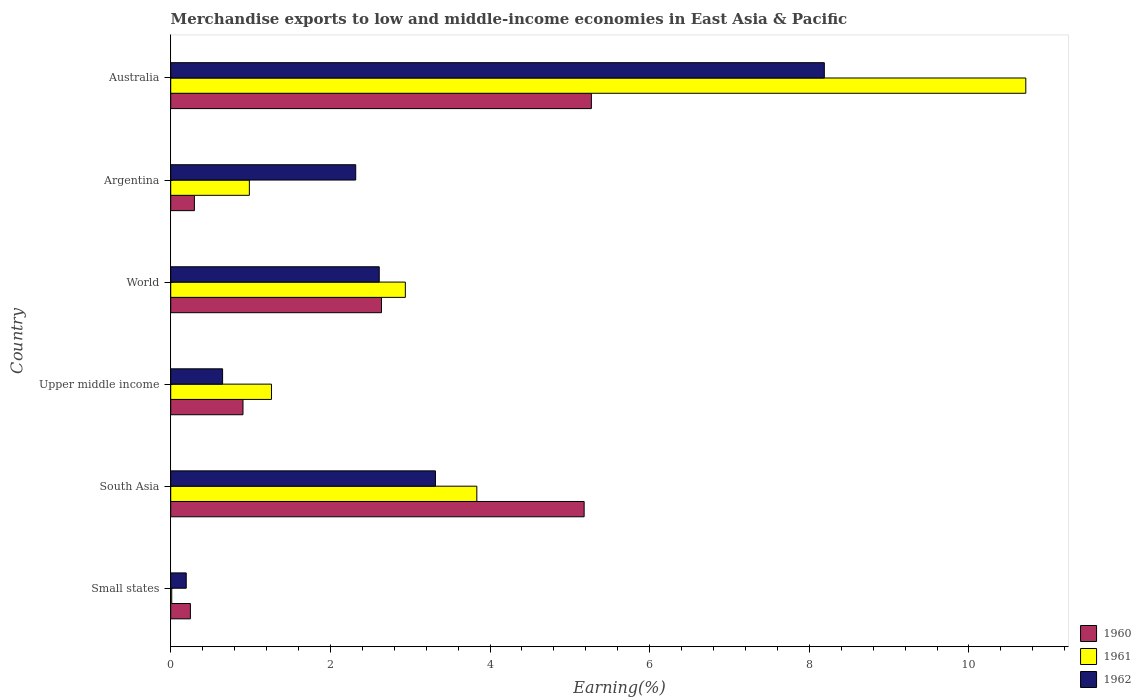How many different coloured bars are there?
Ensure brevity in your answer.  3. How many groups of bars are there?
Ensure brevity in your answer.  6. Are the number of bars per tick equal to the number of legend labels?
Your response must be concise. Yes. How many bars are there on the 5th tick from the top?
Your answer should be very brief. 3. What is the label of the 3rd group of bars from the top?
Your response must be concise. World. In how many cases, is the number of bars for a given country not equal to the number of legend labels?
Make the answer very short. 0. What is the percentage of amount earned from merchandise exports in 1961 in Small states?
Keep it short and to the point. 0.01. Across all countries, what is the maximum percentage of amount earned from merchandise exports in 1962?
Keep it short and to the point. 8.19. Across all countries, what is the minimum percentage of amount earned from merchandise exports in 1960?
Your answer should be compact. 0.25. In which country was the percentage of amount earned from merchandise exports in 1962 maximum?
Your answer should be very brief. Australia. In which country was the percentage of amount earned from merchandise exports in 1960 minimum?
Your answer should be very brief. Small states. What is the total percentage of amount earned from merchandise exports in 1960 in the graph?
Keep it short and to the point. 14.54. What is the difference between the percentage of amount earned from merchandise exports in 1961 in Australia and that in World?
Ensure brevity in your answer.  7.77. What is the difference between the percentage of amount earned from merchandise exports in 1962 in South Asia and the percentage of amount earned from merchandise exports in 1961 in Australia?
Keep it short and to the point. -7.4. What is the average percentage of amount earned from merchandise exports in 1960 per country?
Your response must be concise. 2.42. What is the difference between the percentage of amount earned from merchandise exports in 1961 and percentage of amount earned from merchandise exports in 1960 in Small states?
Offer a very short reply. -0.23. In how many countries, is the percentage of amount earned from merchandise exports in 1961 greater than 7.6 %?
Keep it short and to the point. 1. What is the ratio of the percentage of amount earned from merchandise exports in 1961 in Argentina to that in South Asia?
Give a very brief answer. 0.26. Is the difference between the percentage of amount earned from merchandise exports in 1961 in South Asia and World greater than the difference between the percentage of amount earned from merchandise exports in 1960 in South Asia and World?
Your response must be concise. No. What is the difference between the highest and the second highest percentage of amount earned from merchandise exports in 1962?
Ensure brevity in your answer.  4.87. What is the difference between the highest and the lowest percentage of amount earned from merchandise exports in 1960?
Provide a succinct answer. 5.02. In how many countries, is the percentage of amount earned from merchandise exports in 1962 greater than the average percentage of amount earned from merchandise exports in 1962 taken over all countries?
Your answer should be compact. 2. Is the sum of the percentage of amount earned from merchandise exports in 1960 in Australia and South Asia greater than the maximum percentage of amount earned from merchandise exports in 1961 across all countries?
Keep it short and to the point. No. What does the 3rd bar from the bottom in Australia represents?
Offer a very short reply. 1962. Is it the case that in every country, the sum of the percentage of amount earned from merchandise exports in 1960 and percentage of amount earned from merchandise exports in 1962 is greater than the percentage of amount earned from merchandise exports in 1961?
Offer a terse response. Yes. Are all the bars in the graph horizontal?
Provide a succinct answer. Yes. How many countries are there in the graph?
Your answer should be very brief. 6. Are the values on the major ticks of X-axis written in scientific E-notation?
Your response must be concise. No. What is the title of the graph?
Provide a short and direct response. Merchandise exports to low and middle-income economies in East Asia & Pacific. Does "2011" appear as one of the legend labels in the graph?
Provide a succinct answer. No. What is the label or title of the X-axis?
Your response must be concise. Earning(%). What is the label or title of the Y-axis?
Offer a terse response. Country. What is the Earning(%) of 1960 in Small states?
Give a very brief answer. 0.25. What is the Earning(%) in 1961 in Small states?
Your response must be concise. 0.01. What is the Earning(%) in 1962 in Small states?
Provide a succinct answer. 0.19. What is the Earning(%) of 1960 in South Asia?
Offer a very short reply. 5.18. What is the Earning(%) of 1961 in South Asia?
Your answer should be compact. 3.83. What is the Earning(%) in 1962 in South Asia?
Provide a short and direct response. 3.32. What is the Earning(%) of 1960 in Upper middle income?
Provide a succinct answer. 0.91. What is the Earning(%) of 1961 in Upper middle income?
Your response must be concise. 1.26. What is the Earning(%) in 1962 in Upper middle income?
Give a very brief answer. 0.65. What is the Earning(%) in 1960 in World?
Provide a short and direct response. 2.64. What is the Earning(%) in 1961 in World?
Provide a short and direct response. 2.94. What is the Earning(%) of 1962 in World?
Ensure brevity in your answer.  2.61. What is the Earning(%) of 1960 in Argentina?
Your response must be concise. 0.3. What is the Earning(%) in 1961 in Argentina?
Offer a very short reply. 0.99. What is the Earning(%) in 1962 in Argentina?
Give a very brief answer. 2.32. What is the Earning(%) of 1960 in Australia?
Provide a short and direct response. 5.27. What is the Earning(%) of 1961 in Australia?
Keep it short and to the point. 10.71. What is the Earning(%) of 1962 in Australia?
Offer a very short reply. 8.19. Across all countries, what is the maximum Earning(%) in 1960?
Your answer should be compact. 5.27. Across all countries, what is the maximum Earning(%) in 1961?
Keep it short and to the point. 10.71. Across all countries, what is the maximum Earning(%) in 1962?
Ensure brevity in your answer.  8.19. Across all countries, what is the minimum Earning(%) of 1960?
Provide a short and direct response. 0.25. Across all countries, what is the minimum Earning(%) in 1961?
Your response must be concise. 0.01. Across all countries, what is the minimum Earning(%) in 1962?
Give a very brief answer. 0.19. What is the total Earning(%) in 1960 in the graph?
Your response must be concise. 14.54. What is the total Earning(%) in 1961 in the graph?
Offer a terse response. 19.75. What is the total Earning(%) of 1962 in the graph?
Keep it short and to the point. 17.28. What is the difference between the Earning(%) in 1960 in Small states and that in South Asia?
Make the answer very short. -4.93. What is the difference between the Earning(%) of 1961 in Small states and that in South Asia?
Your answer should be very brief. -3.82. What is the difference between the Earning(%) of 1962 in Small states and that in South Asia?
Ensure brevity in your answer.  -3.12. What is the difference between the Earning(%) in 1960 in Small states and that in Upper middle income?
Ensure brevity in your answer.  -0.66. What is the difference between the Earning(%) in 1961 in Small states and that in Upper middle income?
Keep it short and to the point. -1.25. What is the difference between the Earning(%) of 1962 in Small states and that in Upper middle income?
Give a very brief answer. -0.46. What is the difference between the Earning(%) in 1960 in Small states and that in World?
Ensure brevity in your answer.  -2.39. What is the difference between the Earning(%) in 1961 in Small states and that in World?
Offer a very short reply. -2.93. What is the difference between the Earning(%) of 1962 in Small states and that in World?
Keep it short and to the point. -2.42. What is the difference between the Earning(%) of 1960 in Small states and that in Argentina?
Provide a short and direct response. -0.05. What is the difference between the Earning(%) of 1961 in Small states and that in Argentina?
Your answer should be compact. -0.97. What is the difference between the Earning(%) in 1962 in Small states and that in Argentina?
Your response must be concise. -2.12. What is the difference between the Earning(%) of 1960 in Small states and that in Australia?
Your response must be concise. -5.02. What is the difference between the Earning(%) in 1961 in Small states and that in Australia?
Give a very brief answer. -10.7. What is the difference between the Earning(%) of 1962 in Small states and that in Australia?
Your response must be concise. -7.99. What is the difference between the Earning(%) of 1960 in South Asia and that in Upper middle income?
Your answer should be compact. 4.27. What is the difference between the Earning(%) in 1961 in South Asia and that in Upper middle income?
Your answer should be very brief. 2.57. What is the difference between the Earning(%) of 1962 in South Asia and that in Upper middle income?
Ensure brevity in your answer.  2.67. What is the difference between the Earning(%) of 1960 in South Asia and that in World?
Give a very brief answer. 2.54. What is the difference between the Earning(%) of 1961 in South Asia and that in World?
Keep it short and to the point. 0.9. What is the difference between the Earning(%) of 1962 in South Asia and that in World?
Your answer should be compact. 0.7. What is the difference between the Earning(%) in 1960 in South Asia and that in Argentina?
Your answer should be very brief. 4.88. What is the difference between the Earning(%) in 1961 in South Asia and that in Argentina?
Provide a short and direct response. 2.85. What is the difference between the Earning(%) in 1962 in South Asia and that in Argentina?
Give a very brief answer. 1. What is the difference between the Earning(%) of 1960 in South Asia and that in Australia?
Provide a short and direct response. -0.09. What is the difference between the Earning(%) in 1961 in South Asia and that in Australia?
Give a very brief answer. -6.88. What is the difference between the Earning(%) in 1962 in South Asia and that in Australia?
Ensure brevity in your answer.  -4.87. What is the difference between the Earning(%) in 1960 in Upper middle income and that in World?
Keep it short and to the point. -1.74. What is the difference between the Earning(%) in 1961 in Upper middle income and that in World?
Give a very brief answer. -1.68. What is the difference between the Earning(%) of 1962 in Upper middle income and that in World?
Offer a very short reply. -1.96. What is the difference between the Earning(%) of 1960 in Upper middle income and that in Argentina?
Keep it short and to the point. 0.61. What is the difference between the Earning(%) in 1961 in Upper middle income and that in Argentina?
Your answer should be very brief. 0.28. What is the difference between the Earning(%) of 1962 in Upper middle income and that in Argentina?
Offer a terse response. -1.67. What is the difference between the Earning(%) of 1960 in Upper middle income and that in Australia?
Your answer should be very brief. -4.36. What is the difference between the Earning(%) of 1961 in Upper middle income and that in Australia?
Provide a succinct answer. -9.45. What is the difference between the Earning(%) of 1962 in Upper middle income and that in Australia?
Provide a succinct answer. -7.54. What is the difference between the Earning(%) of 1960 in World and that in Argentina?
Make the answer very short. 2.34. What is the difference between the Earning(%) in 1961 in World and that in Argentina?
Give a very brief answer. 1.95. What is the difference between the Earning(%) of 1962 in World and that in Argentina?
Your response must be concise. 0.29. What is the difference between the Earning(%) of 1960 in World and that in Australia?
Keep it short and to the point. -2.63. What is the difference between the Earning(%) of 1961 in World and that in Australia?
Your answer should be compact. -7.77. What is the difference between the Earning(%) of 1962 in World and that in Australia?
Ensure brevity in your answer.  -5.58. What is the difference between the Earning(%) of 1960 in Argentina and that in Australia?
Ensure brevity in your answer.  -4.97. What is the difference between the Earning(%) in 1961 in Argentina and that in Australia?
Give a very brief answer. -9.73. What is the difference between the Earning(%) of 1962 in Argentina and that in Australia?
Provide a short and direct response. -5.87. What is the difference between the Earning(%) of 1960 in Small states and the Earning(%) of 1961 in South Asia?
Ensure brevity in your answer.  -3.59. What is the difference between the Earning(%) in 1960 in Small states and the Earning(%) in 1962 in South Asia?
Your answer should be very brief. -3.07. What is the difference between the Earning(%) in 1961 in Small states and the Earning(%) in 1962 in South Asia?
Your response must be concise. -3.3. What is the difference between the Earning(%) in 1960 in Small states and the Earning(%) in 1961 in Upper middle income?
Your answer should be compact. -1.02. What is the difference between the Earning(%) in 1960 in Small states and the Earning(%) in 1962 in Upper middle income?
Give a very brief answer. -0.4. What is the difference between the Earning(%) of 1961 in Small states and the Earning(%) of 1962 in Upper middle income?
Offer a very short reply. -0.64. What is the difference between the Earning(%) of 1960 in Small states and the Earning(%) of 1961 in World?
Provide a succinct answer. -2.69. What is the difference between the Earning(%) of 1960 in Small states and the Earning(%) of 1962 in World?
Your answer should be very brief. -2.37. What is the difference between the Earning(%) in 1961 in Small states and the Earning(%) in 1962 in World?
Provide a short and direct response. -2.6. What is the difference between the Earning(%) of 1960 in Small states and the Earning(%) of 1961 in Argentina?
Give a very brief answer. -0.74. What is the difference between the Earning(%) of 1960 in Small states and the Earning(%) of 1962 in Argentina?
Your response must be concise. -2.07. What is the difference between the Earning(%) in 1961 in Small states and the Earning(%) in 1962 in Argentina?
Your response must be concise. -2.3. What is the difference between the Earning(%) in 1960 in Small states and the Earning(%) in 1961 in Australia?
Keep it short and to the point. -10.47. What is the difference between the Earning(%) of 1960 in Small states and the Earning(%) of 1962 in Australia?
Your answer should be compact. -7.94. What is the difference between the Earning(%) of 1961 in Small states and the Earning(%) of 1962 in Australia?
Ensure brevity in your answer.  -8.18. What is the difference between the Earning(%) of 1960 in South Asia and the Earning(%) of 1961 in Upper middle income?
Your answer should be very brief. 3.92. What is the difference between the Earning(%) in 1960 in South Asia and the Earning(%) in 1962 in Upper middle income?
Provide a short and direct response. 4.53. What is the difference between the Earning(%) in 1961 in South Asia and the Earning(%) in 1962 in Upper middle income?
Your answer should be compact. 3.18. What is the difference between the Earning(%) of 1960 in South Asia and the Earning(%) of 1961 in World?
Keep it short and to the point. 2.24. What is the difference between the Earning(%) in 1960 in South Asia and the Earning(%) in 1962 in World?
Your answer should be compact. 2.57. What is the difference between the Earning(%) of 1961 in South Asia and the Earning(%) of 1962 in World?
Offer a terse response. 1.22. What is the difference between the Earning(%) of 1960 in South Asia and the Earning(%) of 1961 in Argentina?
Your answer should be very brief. 4.19. What is the difference between the Earning(%) of 1960 in South Asia and the Earning(%) of 1962 in Argentina?
Offer a very short reply. 2.86. What is the difference between the Earning(%) in 1961 in South Asia and the Earning(%) in 1962 in Argentina?
Your response must be concise. 1.52. What is the difference between the Earning(%) in 1960 in South Asia and the Earning(%) in 1961 in Australia?
Your answer should be very brief. -5.53. What is the difference between the Earning(%) in 1960 in South Asia and the Earning(%) in 1962 in Australia?
Your answer should be compact. -3.01. What is the difference between the Earning(%) of 1961 in South Asia and the Earning(%) of 1962 in Australia?
Your answer should be very brief. -4.35. What is the difference between the Earning(%) of 1960 in Upper middle income and the Earning(%) of 1961 in World?
Keep it short and to the point. -2.03. What is the difference between the Earning(%) of 1960 in Upper middle income and the Earning(%) of 1962 in World?
Ensure brevity in your answer.  -1.71. What is the difference between the Earning(%) of 1961 in Upper middle income and the Earning(%) of 1962 in World?
Provide a succinct answer. -1.35. What is the difference between the Earning(%) in 1960 in Upper middle income and the Earning(%) in 1961 in Argentina?
Provide a short and direct response. -0.08. What is the difference between the Earning(%) in 1960 in Upper middle income and the Earning(%) in 1962 in Argentina?
Give a very brief answer. -1.41. What is the difference between the Earning(%) in 1961 in Upper middle income and the Earning(%) in 1962 in Argentina?
Your answer should be very brief. -1.06. What is the difference between the Earning(%) of 1960 in Upper middle income and the Earning(%) of 1961 in Australia?
Your answer should be very brief. -9.81. What is the difference between the Earning(%) in 1960 in Upper middle income and the Earning(%) in 1962 in Australia?
Keep it short and to the point. -7.28. What is the difference between the Earning(%) in 1961 in Upper middle income and the Earning(%) in 1962 in Australia?
Offer a terse response. -6.93. What is the difference between the Earning(%) of 1960 in World and the Earning(%) of 1961 in Argentina?
Your answer should be compact. 1.66. What is the difference between the Earning(%) of 1960 in World and the Earning(%) of 1962 in Argentina?
Make the answer very short. 0.32. What is the difference between the Earning(%) of 1961 in World and the Earning(%) of 1962 in Argentina?
Your response must be concise. 0.62. What is the difference between the Earning(%) in 1960 in World and the Earning(%) in 1961 in Australia?
Your response must be concise. -8.07. What is the difference between the Earning(%) in 1960 in World and the Earning(%) in 1962 in Australia?
Provide a short and direct response. -5.55. What is the difference between the Earning(%) of 1961 in World and the Earning(%) of 1962 in Australia?
Your response must be concise. -5.25. What is the difference between the Earning(%) in 1960 in Argentina and the Earning(%) in 1961 in Australia?
Give a very brief answer. -10.42. What is the difference between the Earning(%) in 1960 in Argentina and the Earning(%) in 1962 in Australia?
Provide a succinct answer. -7.89. What is the difference between the Earning(%) in 1961 in Argentina and the Earning(%) in 1962 in Australia?
Give a very brief answer. -7.2. What is the average Earning(%) in 1960 per country?
Provide a succinct answer. 2.42. What is the average Earning(%) in 1961 per country?
Your response must be concise. 3.29. What is the average Earning(%) of 1962 per country?
Provide a short and direct response. 2.88. What is the difference between the Earning(%) in 1960 and Earning(%) in 1961 in Small states?
Offer a very short reply. 0.23. What is the difference between the Earning(%) of 1960 and Earning(%) of 1962 in Small states?
Keep it short and to the point. 0.05. What is the difference between the Earning(%) in 1961 and Earning(%) in 1962 in Small states?
Keep it short and to the point. -0.18. What is the difference between the Earning(%) in 1960 and Earning(%) in 1961 in South Asia?
Make the answer very short. 1.34. What is the difference between the Earning(%) in 1960 and Earning(%) in 1962 in South Asia?
Make the answer very short. 1.86. What is the difference between the Earning(%) in 1961 and Earning(%) in 1962 in South Asia?
Give a very brief answer. 0.52. What is the difference between the Earning(%) of 1960 and Earning(%) of 1961 in Upper middle income?
Your response must be concise. -0.36. What is the difference between the Earning(%) in 1960 and Earning(%) in 1962 in Upper middle income?
Your answer should be compact. 0.26. What is the difference between the Earning(%) in 1961 and Earning(%) in 1962 in Upper middle income?
Give a very brief answer. 0.61. What is the difference between the Earning(%) of 1960 and Earning(%) of 1961 in World?
Provide a short and direct response. -0.3. What is the difference between the Earning(%) of 1960 and Earning(%) of 1962 in World?
Make the answer very short. 0.03. What is the difference between the Earning(%) in 1961 and Earning(%) in 1962 in World?
Keep it short and to the point. 0.33. What is the difference between the Earning(%) of 1960 and Earning(%) of 1961 in Argentina?
Provide a succinct answer. -0.69. What is the difference between the Earning(%) of 1960 and Earning(%) of 1962 in Argentina?
Give a very brief answer. -2.02. What is the difference between the Earning(%) of 1961 and Earning(%) of 1962 in Argentina?
Ensure brevity in your answer.  -1.33. What is the difference between the Earning(%) in 1960 and Earning(%) in 1961 in Australia?
Make the answer very short. -5.44. What is the difference between the Earning(%) of 1960 and Earning(%) of 1962 in Australia?
Your response must be concise. -2.92. What is the difference between the Earning(%) of 1961 and Earning(%) of 1962 in Australia?
Your answer should be very brief. 2.52. What is the ratio of the Earning(%) of 1960 in Small states to that in South Asia?
Give a very brief answer. 0.05. What is the ratio of the Earning(%) in 1961 in Small states to that in South Asia?
Make the answer very short. 0. What is the ratio of the Earning(%) in 1962 in Small states to that in South Asia?
Your response must be concise. 0.06. What is the ratio of the Earning(%) in 1960 in Small states to that in Upper middle income?
Provide a succinct answer. 0.27. What is the ratio of the Earning(%) in 1961 in Small states to that in Upper middle income?
Your answer should be compact. 0.01. What is the ratio of the Earning(%) of 1962 in Small states to that in Upper middle income?
Your answer should be compact. 0.3. What is the ratio of the Earning(%) in 1960 in Small states to that in World?
Provide a short and direct response. 0.09. What is the ratio of the Earning(%) of 1961 in Small states to that in World?
Offer a very short reply. 0. What is the ratio of the Earning(%) in 1962 in Small states to that in World?
Make the answer very short. 0.07. What is the ratio of the Earning(%) in 1960 in Small states to that in Argentina?
Your response must be concise. 0.83. What is the ratio of the Earning(%) in 1961 in Small states to that in Argentina?
Ensure brevity in your answer.  0.01. What is the ratio of the Earning(%) in 1962 in Small states to that in Argentina?
Offer a very short reply. 0.08. What is the ratio of the Earning(%) of 1960 in Small states to that in Australia?
Your answer should be very brief. 0.05. What is the ratio of the Earning(%) of 1961 in Small states to that in Australia?
Ensure brevity in your answer.  0. What is the ratio of the Earning(%) of 1962 in Small states to that in Australia?
Your answer should be compact. 0.02. What is the ratio of the Earning(%) of 1960 in South Asia to that in Upper middle income?
Your response must be concise. 5.72. What is the ratio of the Earning(%) in 1961 in South Asia to that in Upper middle income?
Your answer should be very brief. 3.04. What is the ratio of the Earning(%) of 1962 in South Asia to that in Upper middle income?
Ensure brevity in your answer.  5.1. What is the ratio of the Earning(%) of 1960 in South Asia to that in World?
Offer a terse response. 1.96. What is the ratio of the Earning(%) of 1961 in South Asia to that in World?
Make the answer very short. 1.3. What is the ratio of the Earning(%) in 1962 in South Asia to that in World?
Provide a succinct answer. 1.27. What is the ratio of the Earning(%) of 1960 in South Asia to that in Argentina?
Your response must be concise. 17.46. What is the ratio of the Earning(%) of 1961 in South Asia to that in Argentina?
Your response must be concise. 3.89. What is the ratio of the Earning(%) of 1962 in South Asia to that in Argentina?
Ensure brevity in your answer.  1.43. What is the ratio of the Earning(%) of 1960 in South Asia to that in Australia?
Ensure brevity in your answer.  0.98. What is the ratio of the Earning(%) in 1961 in South Asia to that in Australia?
Your response must be concise. 0.36. What is the ratio of the Earning(%) of 1962 in South Asia to that in Australia?
Provide a succinct answer. 0.41. What is the ratio of the Earning(%) of 1960 in Upper middle income to that in World?
Your response must be concise. 0.34. What is the ratio of the Earning(%) of 1961 in Upper middle income to that in World?
Your answer should be very brief. 0.43. What is the ratio of the Earning(%) of 1962 in Upper middle income to that in World?
Your answer should be compact. 0.25. What is the ratio of the Earning(%) of 1960 in Upper middle income to that in Argentina?
Ensure brevity in your answer.  3.05. What is the ratio of the Earning(%) of 1961 in Upper middle income to that in Argentina?
Ensure brevity in your answer.  1.28. What is the ratio of the Earning(%) of 1962 in Upper middle income to that in Argentina?
Ensure brevity in your answer.  0.28. What is the ratio of the Earning(%) of 1960 in Upper middle income to that in Australia?
Keep it short and to the point. 0.17. What is the ratio of the Earning(%) of 1961 in Upper middle income to that in Australia?
Provide a succinct answer. 0.12. What is the ratio of the Earning(%) of 1962 in Upper middle income to that in Australia?
Your response must be concise. 0.08. What is the ratio of the Earning(%) in 1960 in World to that in Argentina?
Make the answer very short. 8.9. What is the ratio of the Earning(%) in 1961 in World to that in Argentina?
Your answer should be compact. 2.98. What is the ratio of the Earning(%) of 1962 in World to that in Argentina?
Offer a terse response. 1.13. What is the ratio of the Earning(%) in 1960 in World to that in Australia?
Ensure brevity in your answer.  0.5. What is the ratio of the Earning(%) of 1961 in World to that in Australia?
Offer a terse response. 0.27. What is the ratio of the Earning(%) in 1962 in World to that in Australia?
Your answer should be compact. 0.32. What is the ratio of the Earning(%) of 1960 in Argentina to that in Australia?
Keep it short and to the point. 0.06. What is the ratio of the Earning(%) in 1961 in Argentina to that in Australia?
Your answer should be very brief. 0.09. What is the ratio of the Earning(%) of 1962 in Argentina to that in Australia?
Your response must be concise. 0.28. What is the difference between the highest and the second highest Earning(%) in 1960?
Provide a succinct answer. 0.09. What is the difference between the highest and the second highest Earning(%) in 1961?
Provide a succinct answer. 6.88. What is the difference between the highest and the second highest Earning(%) of 1962?
Provide a succinct answer. 4.87. What is the difference between the highest and the lowest Earning(%) of 1960?
Give a very brief answer. 5.02. What is the difference between the highest and the lowest Earning(%) of 1961?
Ensure brevity in your answer.  10.7. What is the difference between the highest and the lowest Earning(%) in 1962?
Your answer should be compact. 7.99. 